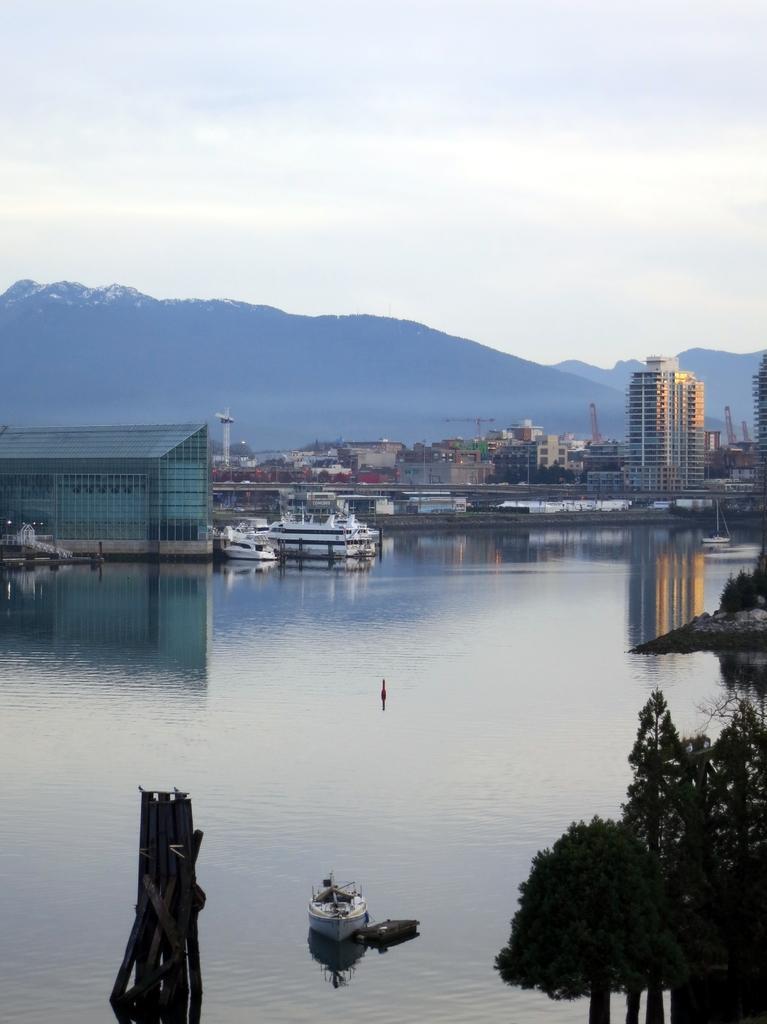Can you describe this image briefly? In this image, we can see some water. We can see some ships sailing on the water. There are a few buildings and trees. We can also see some towers and poles. There are a few hills. We can see the sky and some wood. We can also see a bridge. We can see the reflection of the buildings in the water. 